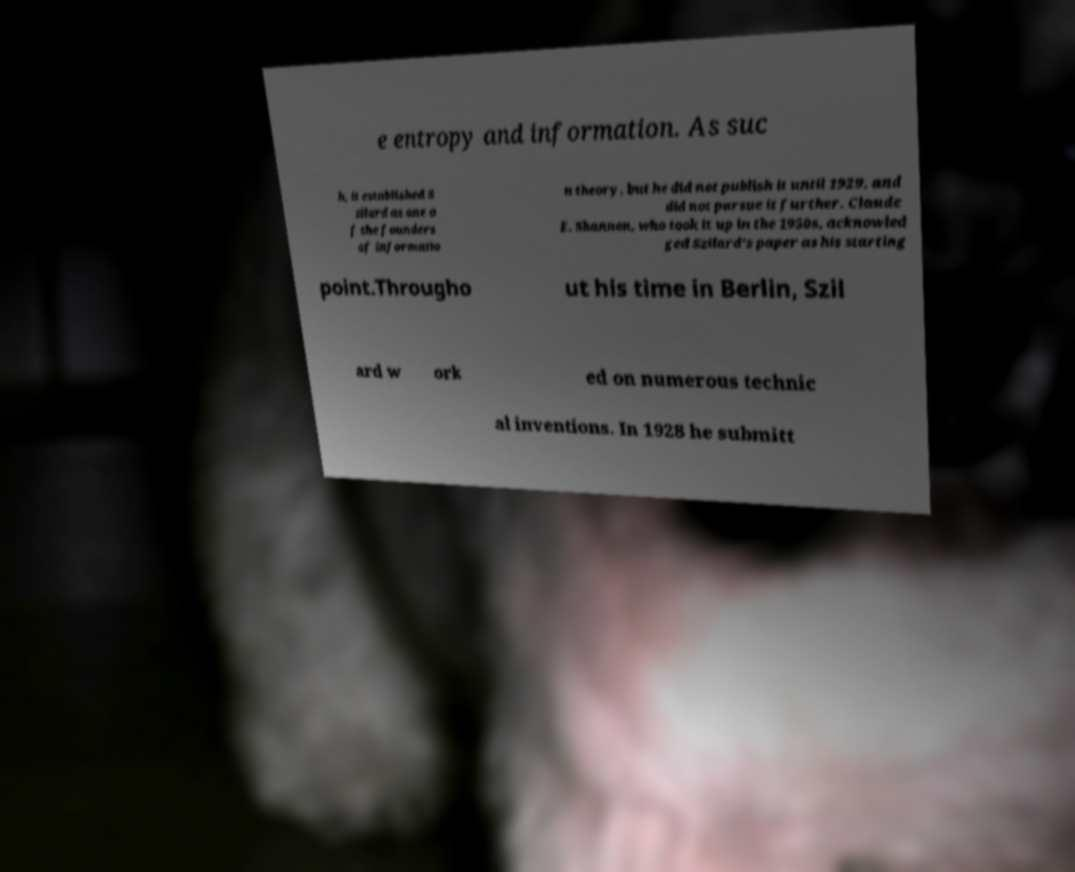Please read and relay the text visible in this image. What does it say? e entropy and information. As suc h, it established S zilard as one o f the founders of informatio n theory, but he did not publish it until 1929, and did not pursue it further. Claude E. Shannon, who took it up in the 1950s, acknowled ged Szilard's paper as his starting point.Througho ut his time in Berlin, Szil ard w ork ed on numerous technic al inventions. In 1928 he submitt 